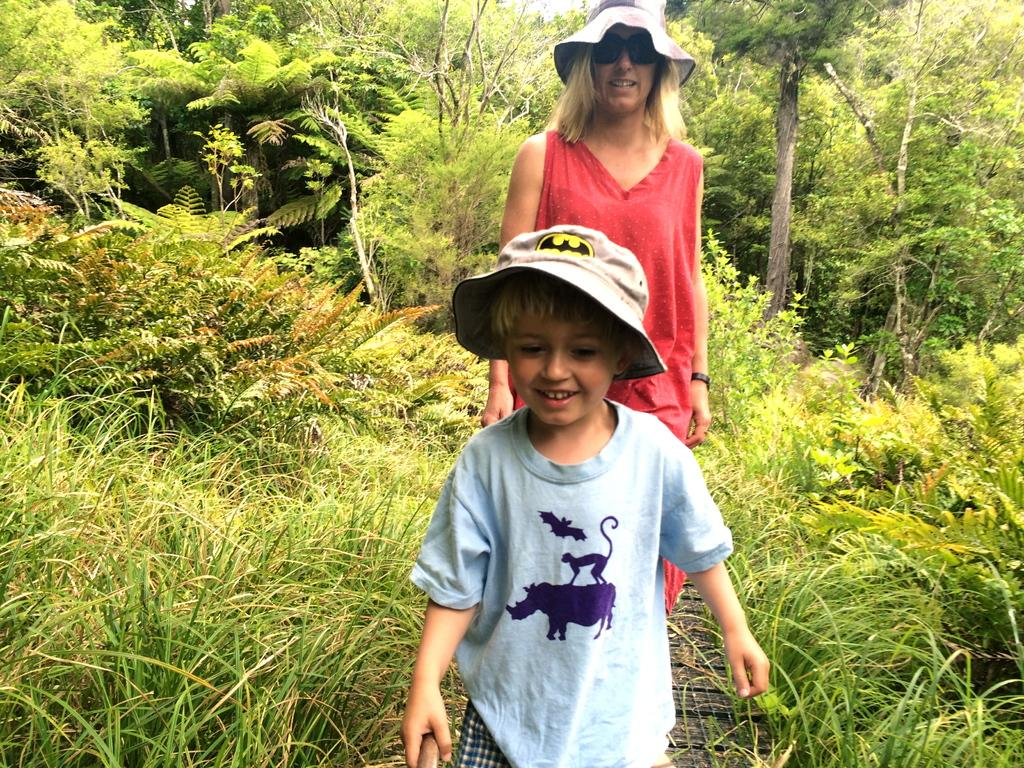Who are the people in the image? There is a boy and a woman in the image. What are they wearing on their heads? Both the boy and the woman are wearing hats. What can be seen in the background of the image? There is a lot of greenery around them. How many ladybugs can be seen on the boy's hat in the image? There are no ladybugs visible on the boy's hat in the image. What type of lead is the woman holding in the image? There is no lead present in the image, and the woman is not holding anything. 